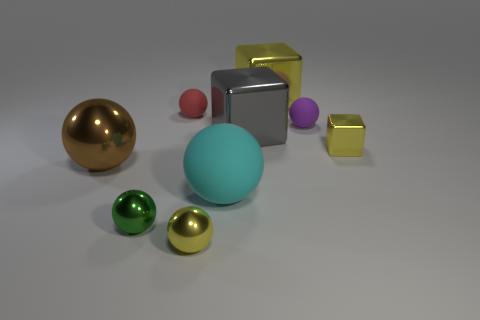Is the small yellow object in front of the brown metal sphere made of the same material as the small yellow cube? It appears that the small yellow object in front of the brown metal sphere shares a similar color and texture with the small yellow cube, suggesting they could be made of the same or similar types of material. However, without more information, it's not possible to determine with certainty if they are indeed made from the exact same substance. 